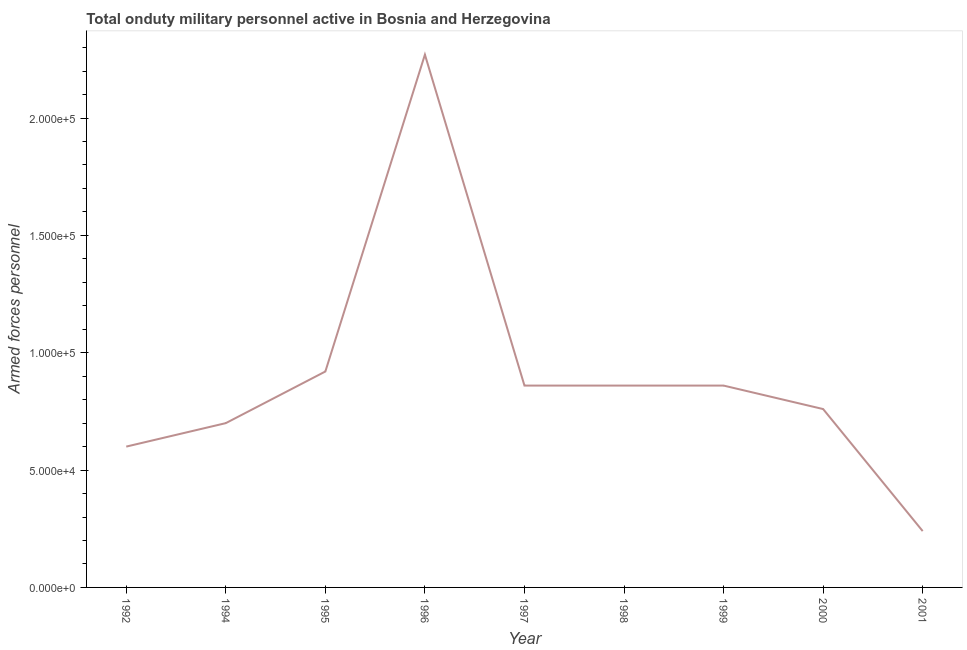What is the number of armed forces personnel in 1994?
Ensure brevity in your answer.  7.00e+04. Across all years, what is the maximum number of armed forces personnel?
Provide a short and direct response. 2.27e+05. Across all years, what is the minimum number of armed forces personnel?
Ensure brevity in your answer.  2.40e+04. What is the sum of the number of armed forces personnel?
Your answer should be very brief. 8.07e+05. What is the difference between the number of armed forces personnel in 1992 and 2001?
Give a very brief answer. 3.60e+04. What is the average number of armed forces personnel per year?
Your answer should be compact. 8.97e+04. What is the median number of armed forces personnel?
Give a very brief answer. 8.60e+04. Do a majority of the years between 1998 and 1999 (inclusive) have number of armed forces personnel greater than 190000 ?
Provide a succinct answer. No. What is the ratio of the number of armed forces personnel in 1992 to that in 2001?
Make the answer very short. 2.5. What is the difference between the highest and the second highest number of armed forces personnel?
Your answer should be very brief. 1.35e+05. Is the sum of the number of armed forces personnel in 1994 and 1996 greater than the maximum number of armed forces personnel across all years?
Provide a succinct answer. Yes. What is the difference between the highest and the lowest number of armed forces personnel?
Provide a short and direct response. 2.03e+05. How many years are there in the graph?
Make the answer very short. 9. What is the title of the graph?
Provide a succinct answer. Total onduty military personnel active in Bosnia and Herzegovina. What is the label or title of the Y-axis?
Provide a short and direct response. Armed forces personnel. What is the Armed forces personnel in 1994?
Your answer should be very brief. 7.00e+04. What is the Armed forces personnel of 1995?
Offer a very short reply. 9.20e+04. What is the Armed forces personnel in 1996?
Ensure brevity in your answer.  2.27e+05. What is the Armed forces personnel of 1997?
Your answer should be very brief. 8.60e+04. What is the Armed forces personnel of 1998?
Make the answer very short. 8.60e+04. What is the Armed forces personnel of 1999?
Ensure brevity in your answer.  8.60e+04. What is the Armed forces personnel of 2000?
Make the answer very short. 7.60e+04. What is the Armed forces personnel in 2001?
Your answer should be very brief. 2.40e+04. What is the difference between the Armed forces personnel in 1992 and 1995?
Ensure brevity in your answer.  -3.20e+04. What is the difference between the Armed forces personnel in 1992 and 1996?
Keep it short and to the point. -1.67e+05. What is the difference between the Armed forces personnel in 1992 and 1997?
Make the answer very short. -2.60e+04. What is the difference between the Armed forces personnel in 1992 and 1998?
Your answer should be compact. -2.60e+04. What is the difference between the Armed forces personnel in 1992 and 1999?
Give a very brief answer. -2.60e+04. What is the difference between the Armed forces personnel in 1992 and 2000?
Offer a very short reply. -1.60e+04. What is the difference between the Armed forces personnel in 1992 and 2001?
Give a very brief answer. 3.60e+04. What is the difference between the Armed forces personnel in 1994 and 1995?
Your answer should be very brief. -2.20e+04. What is the difference between the Armed forces personnel in 1994 and 1996?
Your answer should be very brief. -1.57e+05. What is the difference between the Armed forces personnel in 1994 and 1997?
Make the answer very short. -1.60e+04. What is the difference between the Armed forces personnel in 1994 and 1998?
Make the answer very short. -1.60e+04. What is the difference between the Armed forces personnel in 1994 and 1999?
Offer a terse response. -1.60e+04. What is the difference between the Armed forces personnel in 1994 and 2000?
Your answer should be compact. -6000. What is the difference between the Armed forces personnel in 1994 and 2001?
Offer a very short reply. 4.60e+04. What is the difference between the Armed forces personnel in 1995 and 1996?
Your response must be concise. -1.35e+05. What is the difference between the Armed forces personnel in 1995 and 1997?
Your answer should be compact. 6000. What is the difference between the Armed forces personnel in 1995 and 1998?
Give a very brief answer. 6000. What is the difference between the Armed forces personnel in 1995 and 1999?
Your answer should be very brief. 6000. What is the difference between the Armed forces personnel in 1995 and 2000?
Ensure brevity in your answer.  1.60e+04. What is the difference between the Armed forces personnel in 1995 and 2001?
Offer a very short reply. 6.80e+04. What is the difference between the Armed forces personnel in 1996 and 1997?
Your answer should be compact. 1.41e+05. What is the difference between the Armed forces personnel in 1996 and 1998?
Keep it short and to the point. 1.41e+05. What is the difference between the Armed forces personnel in 1996 and 1999?
Provide a succinct answer. 1.41e+05. What is the difference between the Armed forces personnel in 1996 and 2000?
Keep it short and to the point. 1.51e+05. What is the difference between the Armed forces personnel in 1996 and 2001?
Offer a very short reply. 2.03e+05. What is the difference between the Armed forces personnel in 1997 and 2000?
Ensure brevity in your answer.  10000. What is the difference between the Armed forces personnel in 1997 and 2001?
Make the answer very short. 6.20e+04. What is the difference between the Armed forces personnel in 1998 and 2000?
Provide a short and direct response. 10000. What is the difference between the Armed forces personnel in 1998 and 2001?
Provide a succinct answer. 6.20e+04. What is the difference between the Armed forces personnel in 1999 and 2001?
Your answer should be very brief. 6.20e+04. What is the difference between the Armed forces personnel in 2000 and 2001?
Make the answer very short. 5.20e+04. What is the ratio of the Armed forces personnel in 1992 to that in 1994?
Your answer should be compact. 0.86. What is the ratio of the Armed forces personnel in 1992 to that in 1995?
Ensure brevity in your answer.  0.65. What is the ratio of the Armed forces personnel in 1992 to that in 1996?
Offer a very short reply. 0.26. What is the ratio of the Armed forces personnel in 1992 to that in 1997?
Your answer should be very brief. 0.7. What is the ratio of the Armed forces personnel in 1992 to that in 1998?
Your answer should be very brief. 0.7. What is the ratio of the Armed forces personnel in 1992 to that in 1999?
Provide a succinct answer. 0.7. What is the ratio of the Armed forces personnel in 1992 to that in 2000?
Offer a very short reply. 0.79. What is the ratio of the Armed forces personnel in 1994 to that in 1995?
Ensure brevity in your answer.  0.76. What is the ratio of the Armed forces personnel in 1994 to that in 1996?
Your answer should be compact. 0.31. What is the ratio of the Armed forces personnel in 1994 to that in 1997?
Your response must be concise. 0.81. What is the ratio of the Armed forces personnel in 1994 to that in 1998?
Provide a short and direct response. 0.81. What is the ratio of the Armed forces personnel in 1994 to that in 1999?
Ensure brevity in your answer.  0.81. What is the ratio of the Armed forces personnel in 1994 to that in 2000?
Offer a terse response. 0.92. What is the ratio of the Armed forces personnel in 1994 to that in 2001?
Your answer should be very brief. 2.92. What is the ratio of the Armed forces personnel in 1995 to that in 1996?
Your answer should be compact. 0.41. What is the ratio of the Armed forces personnel in 1995 to that in 1997?
Offer a terse response. 1.07. What is the ratio of the Armed forces personnel in 1995 to that in 1998?
Ensure brevity in your answer.  1.07. What is the ratio of the Armed forces personnel in 1995 to that in 1999?
Keep it short and to the point. 1.07. What is the ratio of the Armed forces personnel in 1995 to that in 2000?
Offer a very short reply. 1.21. What is the ratio of the Armed forces personnel in 1995 to that in 2001?
Ensure brevity in your answer.  3.83. What is the ratio of the Armed forces personnel in 1996 to that in 1997?
Keep it short and to the point. 2.64. What is the ratio of the Armed forces personnel in 1996 to that in 1998?
Your answer should be very brief. 2.64. What is the ratio of the Armed forces personnel in 1996 to that in 1999?
Make the answer very short. 2.64. What is the ratio of the Armed forces personnel in 1996 to that in 2000?
Your answer should be compact. 2.99. What is the ratio of the Armed forces personnel in 1996 to that in 2001?
Your response must be concise. 9.46. What is the ratio of the Armed forces personnel in 1997 to that in 1999?
Offer a very short reply. 1. What is the ratio of the Armed forces personnel in 1997 to that in 2000?
Give a very brief answer. 1.13. What is the ratio of the Armed forces personnel in 1997 to that in 2001?
Your answer should be very brief. 3.58. What is the ratio of the Armed forces personnel in 1998 to that in 1999?
Provide a succinct answer. 1. What is the ratio of the Armed forces personnel in 1998 to that in 2000?
Provide a short and direct response. 1.13. What is the ratio of the Armed forces personnel in 1998 to that in 2001?
Keep it short and to the point. 3.58. What is the ratio of the Armed forces personnel in 1999 to that in 2000?
Your answer should be compact. 1.13. What is the ratio of the Armed forces personnel in 1999 to that in 2001?
Offer a very short reply. 3.58. What is the ratio of the Armed forces personnel in 2000 to that in 2001?
Provide a short and direct response. 3.17. 